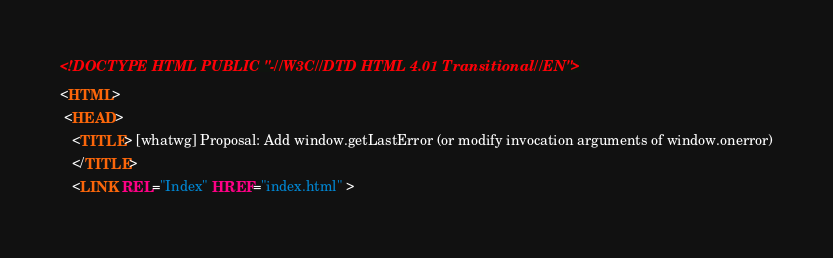Convert code to text. <code><loc_0><loc_0><loc_500><loc_500><_HTML_><!DOCTYPE HTML PUBLIC "-//W3C//DTD HTML 4.01 Transitional//EN">
<HTML>
 <HEAD>
   <TITLE> [whatwg] Proposal: Add window.getLastError (or modify invocation arguments of window.onerror)
   </TITLE>
   <LINK REL="Index" HREF="index.html" ></code> 